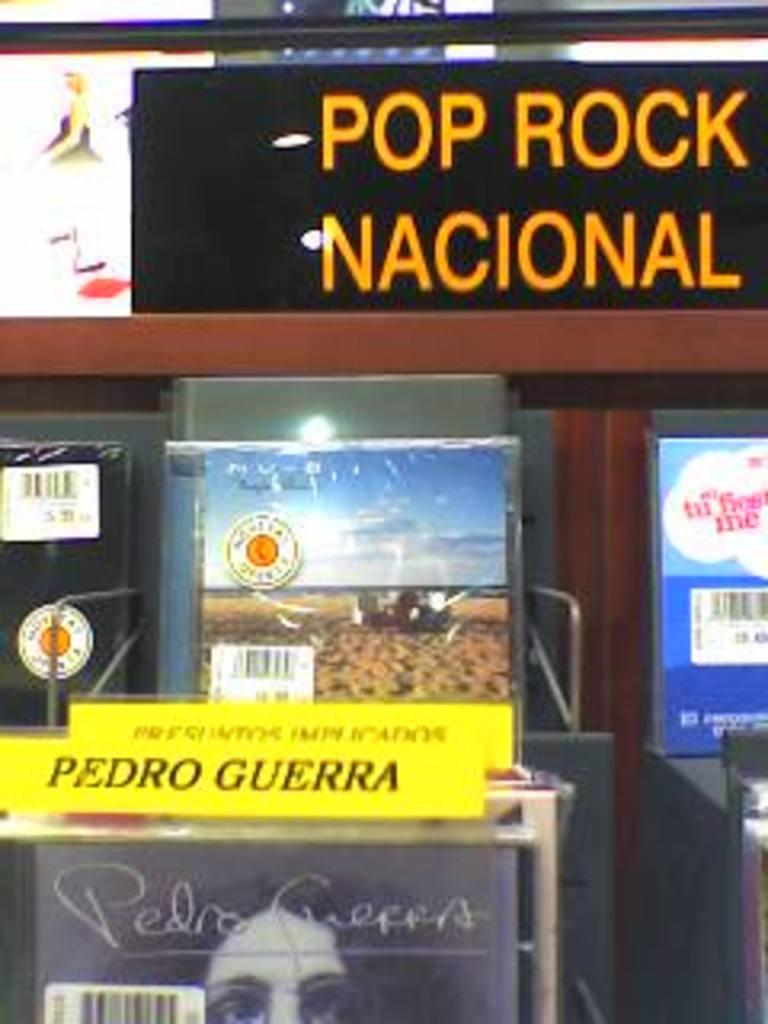What can be seen on the boards in the image? There are boards with text in the image. What other objects are present in the image? There are boxes in the image. Where is the glass located in the image? The glass is at the top of the image. What type of polish is being applied to the grapes in the image? There are no grapes or polish present in the image; it only features boards with text, boxes, and a glass. 